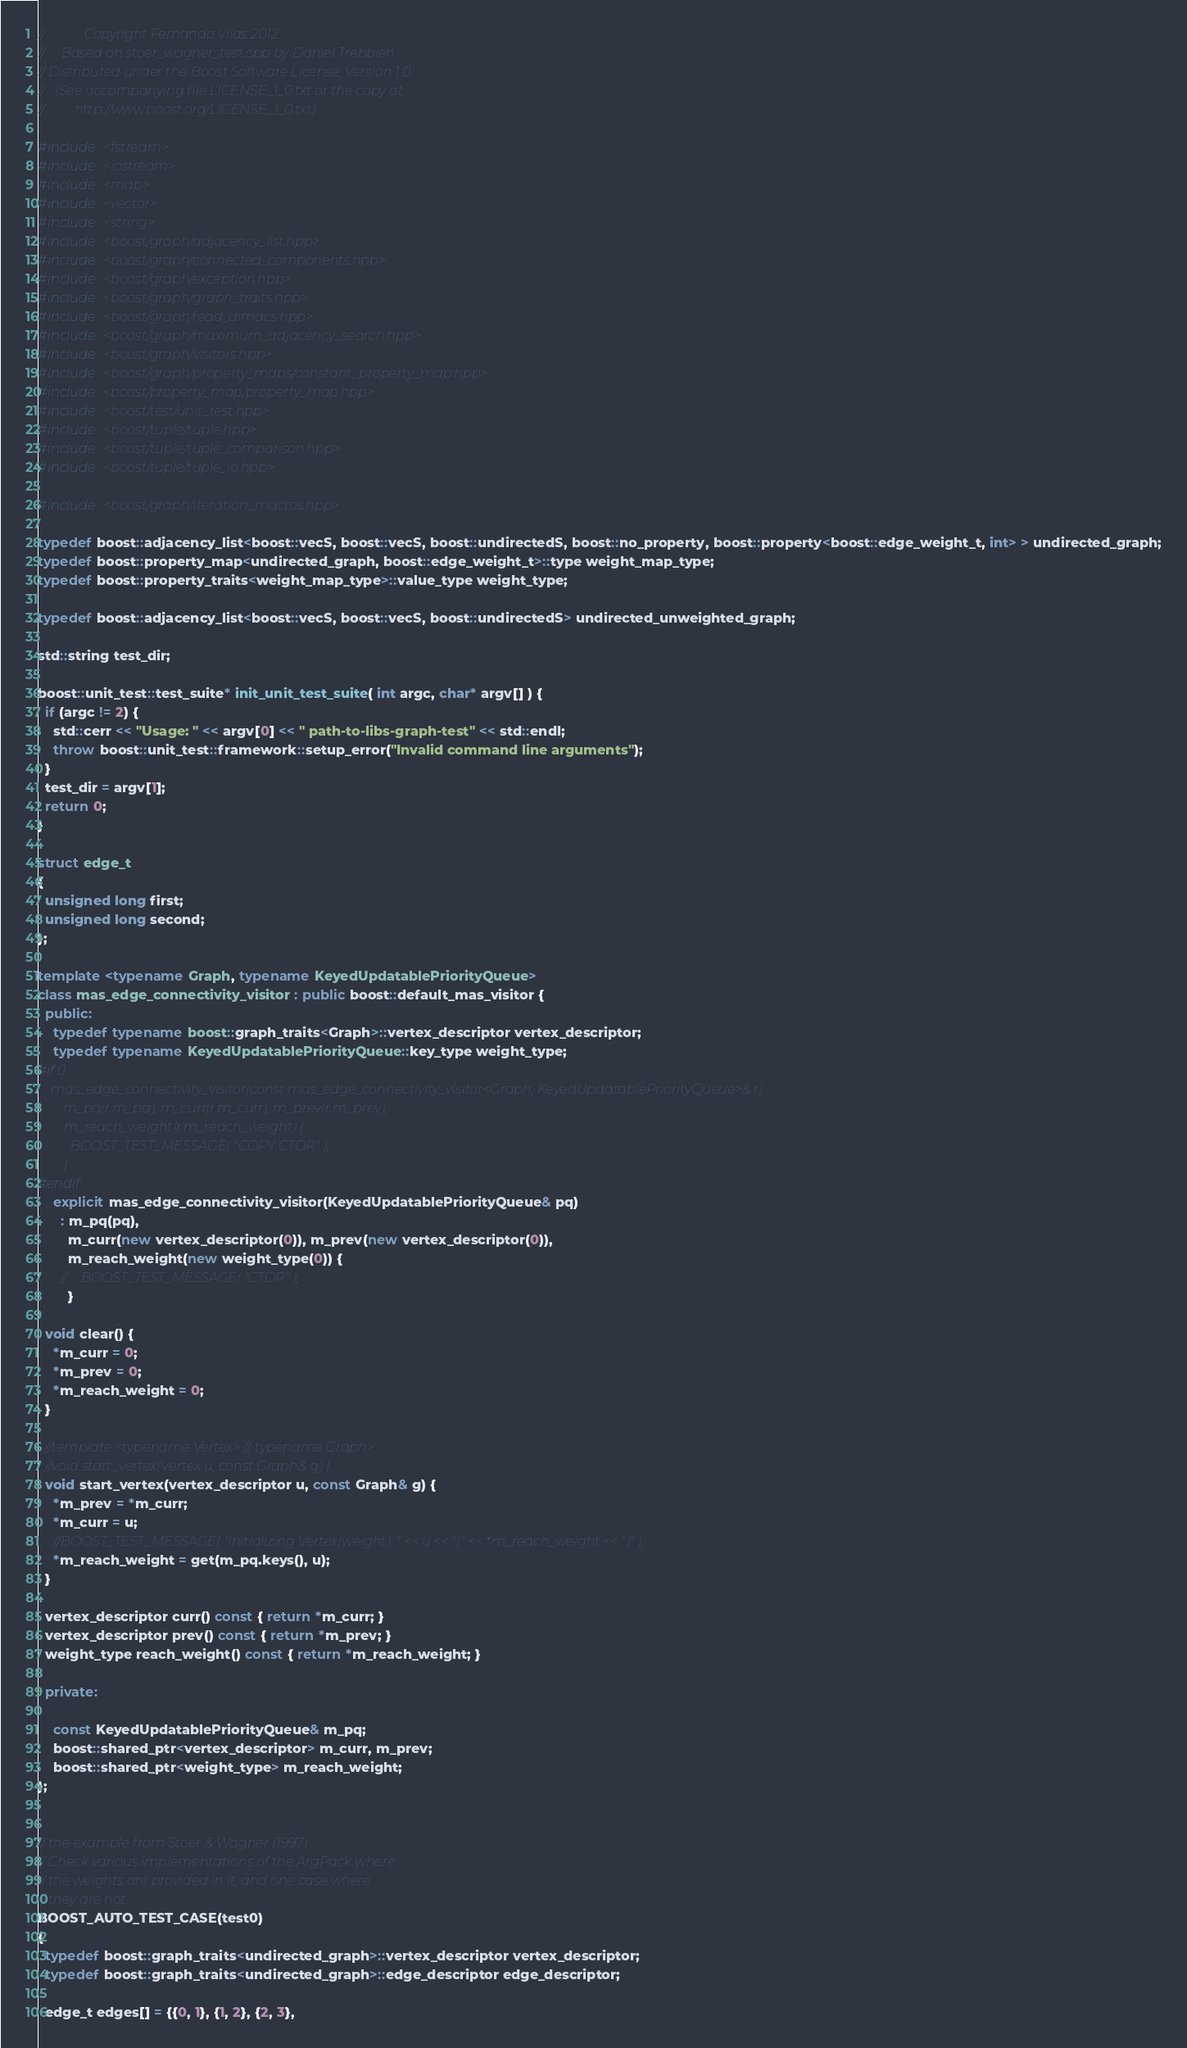Convert code to text. <code><loc_0><loc_0><loc_500><loc_500><_C++_>//            Copyright Fernando Vilas 2012.
//     Based on stoer_wagner_test.cpp by Daniel Trebbien.
// Distributed under the Boost Software License, Version 1.0.
//   (See accompanying file LICENSE_1_0.txt or the copy at
//         http://www.boost.org/LICENSE_1_0.txt)

#include <fstream>
#include <iostream>
#include <map>
#include <vector>
#include <string>
#include <boost/graph/adjacency_list.hpp>
#include <boost/graph/connected_components.hpp>
#include <boost/graph/exception.hpp>
#include <boost/graph/graph_traits.hpp>
#include <boost/graph/read_dimacs.hpp>
#include <boost/graph/maximum_adjacency_search.hpp>
#include <boost/graph/visitors.hpp>
#include <boost/graph/property_maps/constant_property_map.hpp>
#include <boost/property_map/property_map.hpp>
#include <boost/test/unit_test.hpp>
#include <boost/tuple/tuple.hpp>
#include <boost/tuple/tuple_comparison.hpp>
#include <boost/tuple/tuple_io.hpp>

#include <boost/graph/iteration_macros.hpp>

typedef boost::adjacency_list<boost::vecS, boost::vecS, boost::undirectedS, boost::no_property, boost::property<boost::edge_weight_t, int> > undirected_graph;
typedef boost::property_map<undirected_graph, boost::edge_weight_t>::type weight_map_type;
typedef boost::property_traits<weight_map_type>::value_type weight_type;

typedef boost::adjacency_list<boost::vecS, boost::vecS, boost::undirectedS> undirected_unweighted_graph;

std::string test_dir;

boost::unit_test::test_suite* init_unit_test_suite( int argc, char* argv[] ) {
  if (argc != 2) {
    std::cerr << "Usage: " << argv[0] << " path-to-libs-graph-test" << std::endl;
    throw boost::unit_test::framework::setup_error("Invalid command line arguments");
  }
  test_dir = argv[1];
  return 0;
}

struct edge_t
{
  unsigned long first;
  unsigned long second;
};

template <typename Graph, typename KeyedUpdatablePriorityQueue>
class mas_edge_connectivity_visitor : public boost::default_mas_visitor {
  public:
    typedef typename boost::graph_traits<Graph>::vertex_descriptor vertex_descriptor;
    typedef typename KeyedUpdatablePriorityQueue::key_type weight_type;
#if 0
    mas_edge_connectivity_visitor(const mas_edge_connectivity_visitor<Graph, KeyedUpdatablePriorityQueue>& r)
      : m_pq(r.m_pq), m_curr(r.m_curr), m_prev(r.m_prev), 
        m_reach_weight(r.m_reach_weight) {
          BOOST_TEST_MESSAGE( "COPY CTOR" );
        }
#endif
    explicit mas_edge_connectivity_visitor(KeyedUpdatablePriorityQueue& pq)
      : m_pq(pq),
        m_curr(new vertex_descriptor(0)), m_prev(new vertex_descriptor(0)),
        m_reach_weight(new weight_type(0)) {
      //    BOOST_TEST_MESSAGE( "CTOR" );
        }

  void clear() {
    *m_curr = 0;
    *m_prev = 0;
    *m_reach_weight = 0;
  }

  //template <typename Vertex> //, typename Graph>
  //void start_vertex(Vertex u, const Graph& g) {
  void start_vertex(vertex_descriptor u, const Graph& g) {
    *m_prev = *m_curr;
    *m_curr = u;
    //BOOST_TEST_MESSAGE( "Initializing Vertex(weight): " << u << "(" << *m_reach_weight << ")" );
    *m_reach_weight = get(m_pq.keys(), u);
  }

  vertex_descriptor curr() const { return *m_curr; }
  vertex_descriptor prev() const { return *m_prev; }
  weight_type reach_weight() const { return *m_reach_weight; }

  private:

    const KeyedUpdatablePriorityQueue& m_pq;
    boost::shared_ptr<vertex_descriptor> m_curr, m_prev;
    boost::shared_ptr<weight_type> m_reach_weight;
};


// the example from Stoer & Wagner (1997)
// Check various implementations of the ArgPack where
// the weights are provided in it, and one case where
// they are not.
BOOST_AUTO_TEST_CASE(test0)
{
  typedef boost::graph_traits<undirected_graph>::vertex_descriptor vertex_descriptor;
  typedef boost::graph_traits<undirected_graph>::edge_descriptor edge_descriptor;

  edge_t edges[] = {{0, 1}, {1, 2}, {2, 3},</code> 